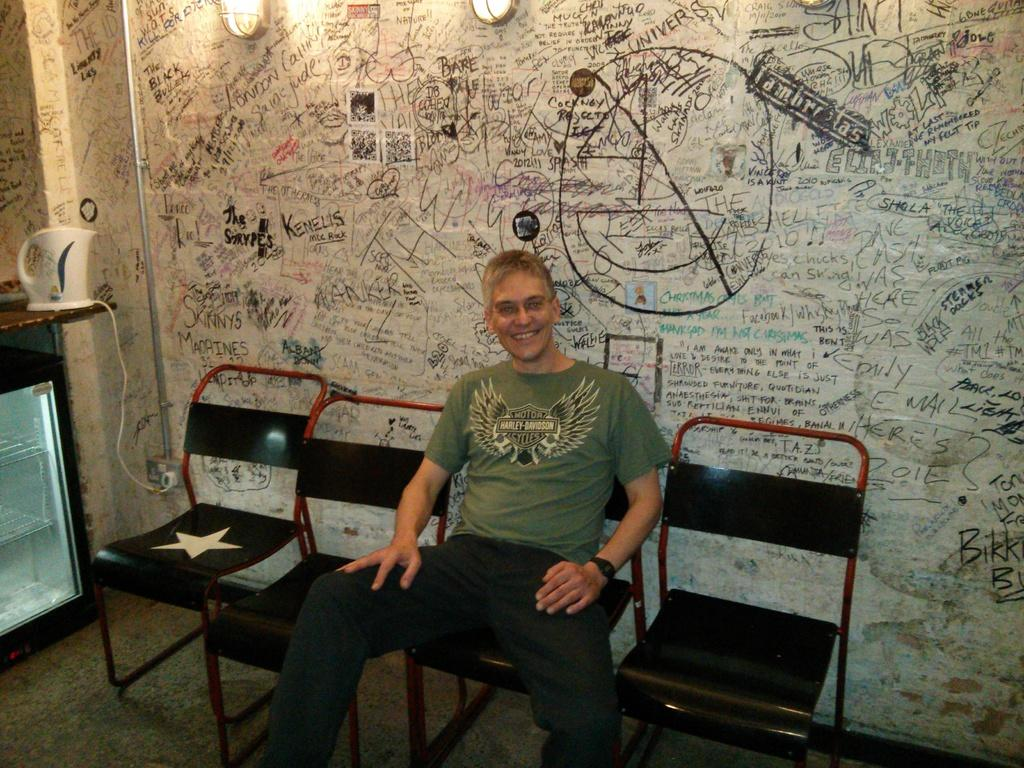Who is present in the image? There is a man in the image. What is the man doing in the image? The man is sitting in a chair. How many chairs are visible in the image? There are four chairs in the image. What can be seen in the background of the image? There is a wall and lights in the background of the image. What is the man's facial expression in the image? The man is smiling in the image. What type of sack can be seen hanging from the wall in the image? There is no sack present in the image, and therefore no such object can be observed hanging from the wall. 